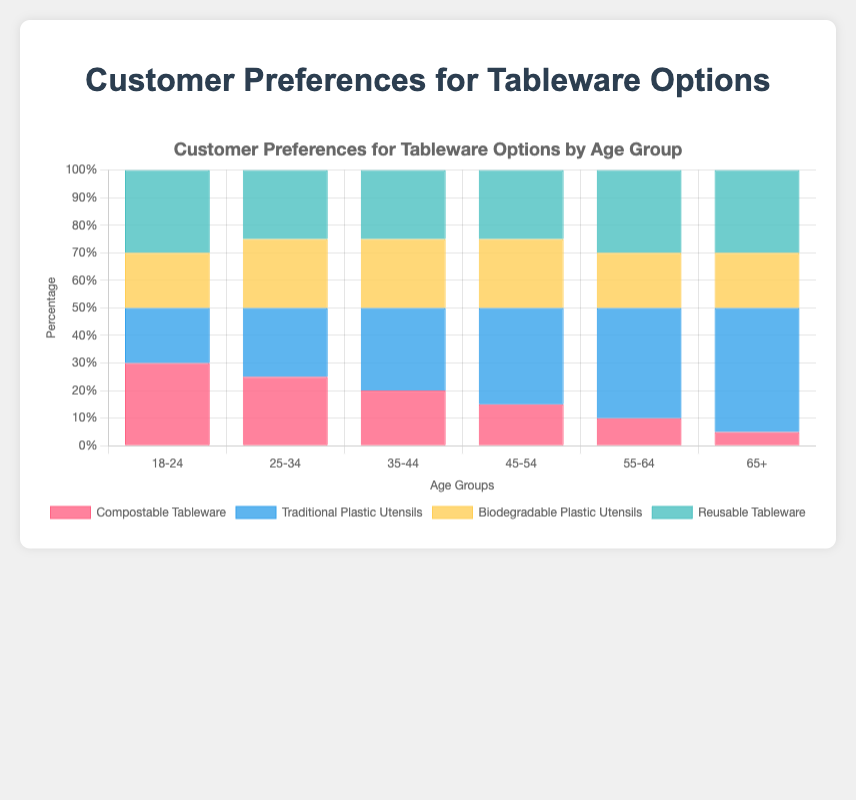Which age group has the highest preference for Traditional Plastic Utensils? Looking at the height of the bars for Traditional Plastic Utensils category, the group 65+ has the highest bar.
Answer: 65+ Which age group prefers Compostable Tableware the least? The shortest bar in the Compostable Tableware category represents the age group 65+.
Answer: 65+ Compare the preferences for Traditional Plastic Utensils and Compostable Tableware among the 18-24 age group. Which one is higher and by how much? For the 18-24 age group, Traditional Plastic Utensils have a value of 20%, while Compostable Tableware is at 30%. The difference is 30% - 20% = 10%.
Answer: Compostable Tableware by 10% Which age group has an equal preference for Biodegradable Plastic Utensils and Reusable Tableware? The bars for the 25-34 age group are both at 25% for Biodegradable Plastic Utensils and Reusable Tableware.
Answer: 25-34 Summing up the preferences for the 55-64 age group, what is the combined percentage for all tableware options? The values for the 55-64 age group across all categories are: Compostable Tableware (10%), Traditional Plastic Utensils (40%), Biodegradable Plastic Utensils (20%), and Reusable Tableware (30%). Summing these gives 10% + 40% + 20% + 30% = 100%.
Answer: 100% For the 35-44 age group, which tableware option is the most and least preferred, and what is the difference between them? The 35-44 age group's values: Compostable Tableware (20%), Traditional Plastic Utensils (30%), Biodegradable Plastic Utensils (25%), and Reusable Tableware (25%). The highest preference is for Traditional Plastic Utensils (30%) and the lowest for Compostable Tableware (20%), with a difference of 10%.
Answer: Traditional Plastic Utensils most, Compostable Tableware least, 10% How do the preferences for Reusable Tableware change across age groups? The values for Reusable Tableware across the age groups are 18-24 (30%), 25-34 (25%), 35-44 (25%), 45-54 (25%), 55-64 (30%), 65+ (30%). Preferences are consistent, with a slight increase in the 18-24 and 55+ age groups.
Answer: Mostly constant, slight increase in 18-24 and 55+ Which two age groups have the exact same preference distributions across all tableware options? By comparing the heights across all categories, age groups 25-34 and 45-54 have the same preferences: Compostable Tableware (25%), Traditional Plastic Utensils (25%), Biodegradable Plastic Utensils (25%), and Reusable Tableware (25%).
Answer: 25-34 and 45-54 